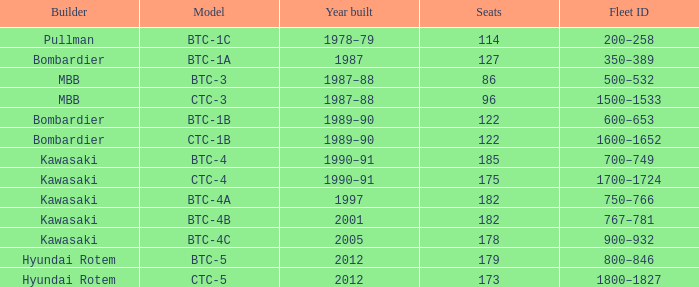How many seats does the BTC-5 model have? 179.0. 